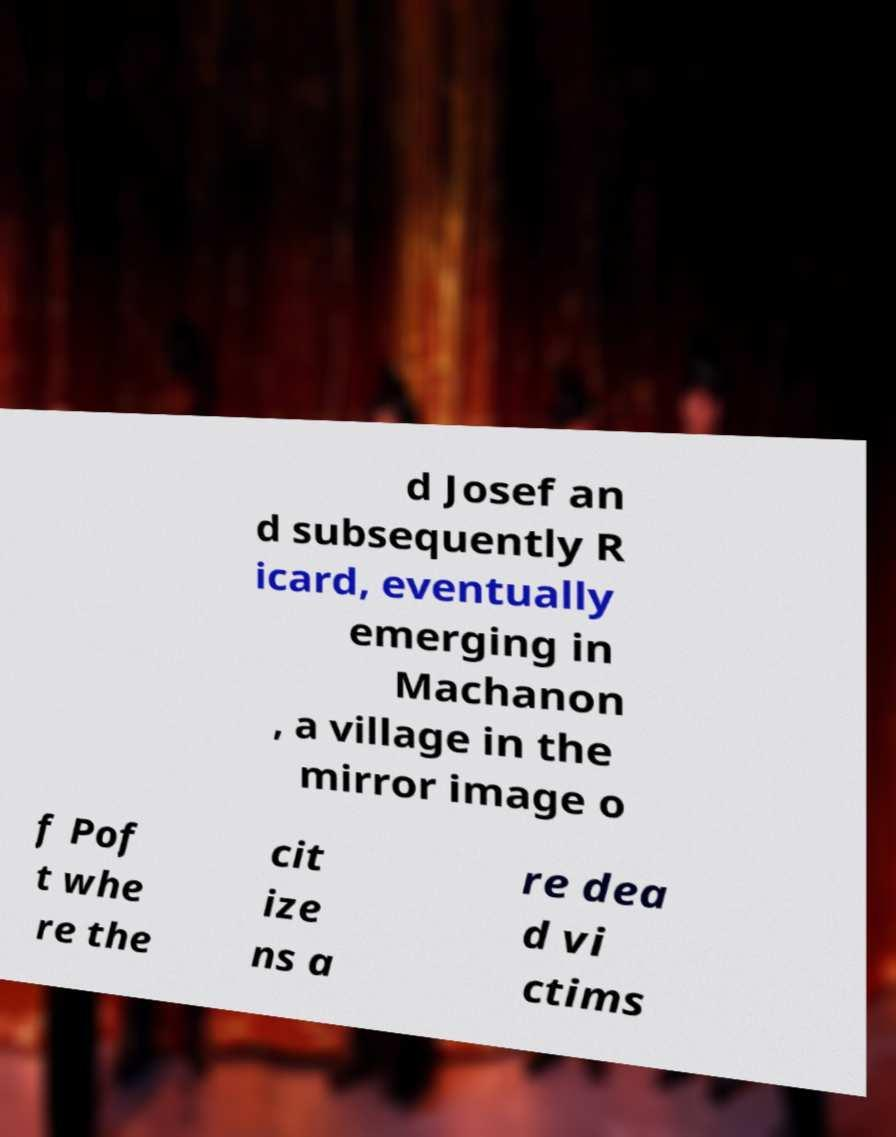Could you assist in decoding the text presented in this image and type it out clearly? d Josef an d subsequently R icard, eventually emerging in Machanon , a village in the mirror image o f Pof t whe re the cit ize ns a re dea d vi ctims 